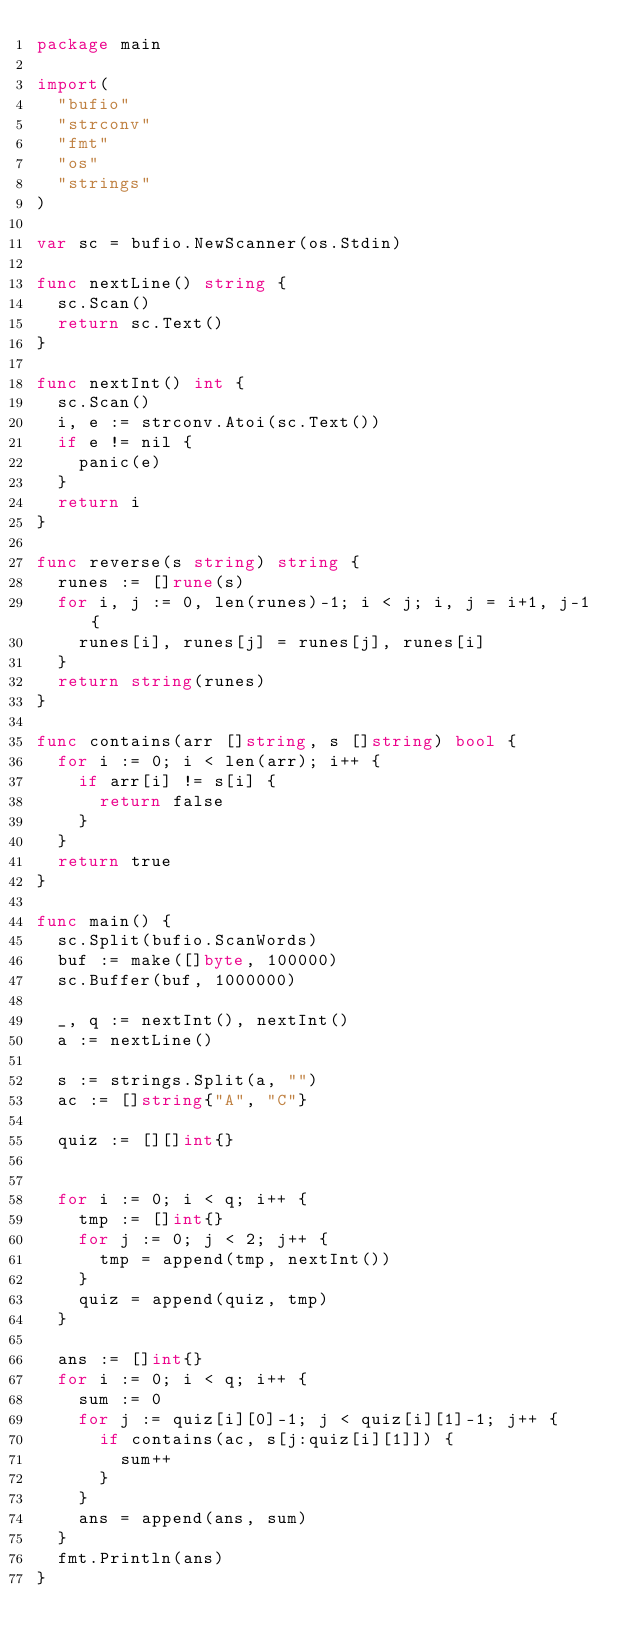<code> <loc_0><loc_0><loc_500><loc_500><_Go_>package main

import(
	"bufio"
	"strconv"
	"fmt"
	"os"
	"strings"
)

var sc = bufio.NewScanner(os.Stdin)

func nextLine() string {
	sc.Scan()
	return sc.Text()
}

func nextInt() int {
	sc.Scan()
	i, e := strconv.Atoi(sc.Text())
	if e != nil {
		panic(e)
	}
	return i
}

func reverse(s string) string {
	runes := []rune(s)
	for i, j := 0, len(runes)-1; i < j; i, j = i+1, j-1 {
		runes[i], runes[j] = runes[j], runes[i]
	}
	return string(runes)
}

func contains(arr []string, s []string) bool {
	for i := 0; i < len(arr); i++ {
		if arr[i] != s[i] {
			return false
		}
	}
	return true
}

func main() {
	sc.Split(bufio.ScanWords)
	buf := make([]byte, 100000)
	sc.Buffer(buf, 1000000)

	_, q := nextInt(), nextInt()
	a := nextLine()

	s := strings.Split(a, "")
	ac := []string{"A", "C"}

	quiz := [][]int{}


	for i := 0; i < q; i++ {
		tmp := []int{}
		for j := 0; j < 2; j++ {
			tmp = append(tmp, nextInt())
		}
		quiz = append(quiz, tmp)
	}

	ans := []int{}
	for i := 0; i < q; i++ {
		sum := 0
		for j := quiz[i][0]-1; j < quiz[i][1]-1; j++ {
			if contains(ac, s[j:quiz[i][1]]) {
				sum++
			}
		}
		ans = append(ans, sum)
	}
	fmt.Println(ans)
}
</code> 